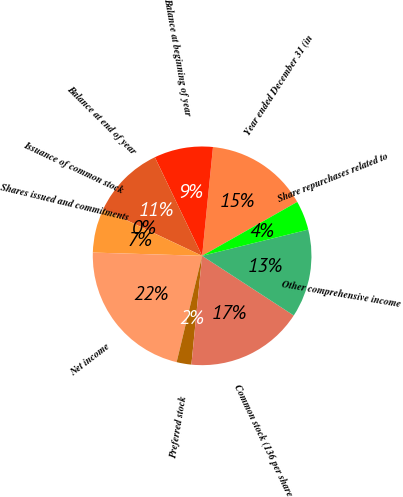<chart> <loc_0><loc_0><loc_500><loc_500><pie_chart><fcel>Year ended December 31 (in<fcel>Balance at beginning of year<fcel>Balance at end of year<fcel>Issuance of common stock<fcel>Shares issued and commitments<fcel>Net income<fcel>Preferred stock<fcel>Common stock (136 per share<fcel>Other comprehensive income<fcel>Share repurchases related to<nl><fcel>15.21%<fcel>8.7%<fcel>10.87%<fcel>0.01%<fcel>6.53%<fcel>21.73%<fcel>2.18%<fcel>17.38%<fcel>13.04%<fcel>4.35%<nl></chart> 